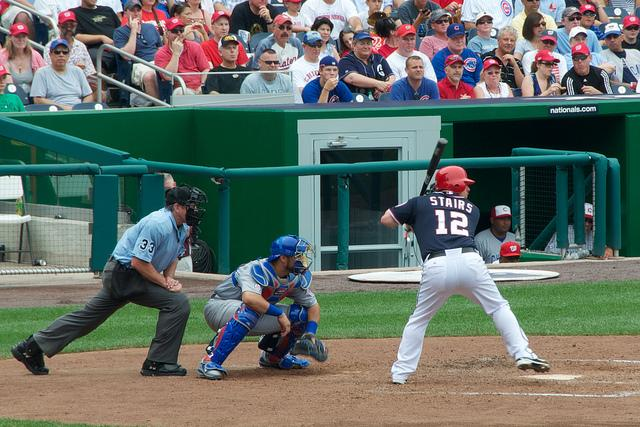What team does the catcher play for?

Choices:
A) cubs
B) yankees
C) astros
D) mets cubs 